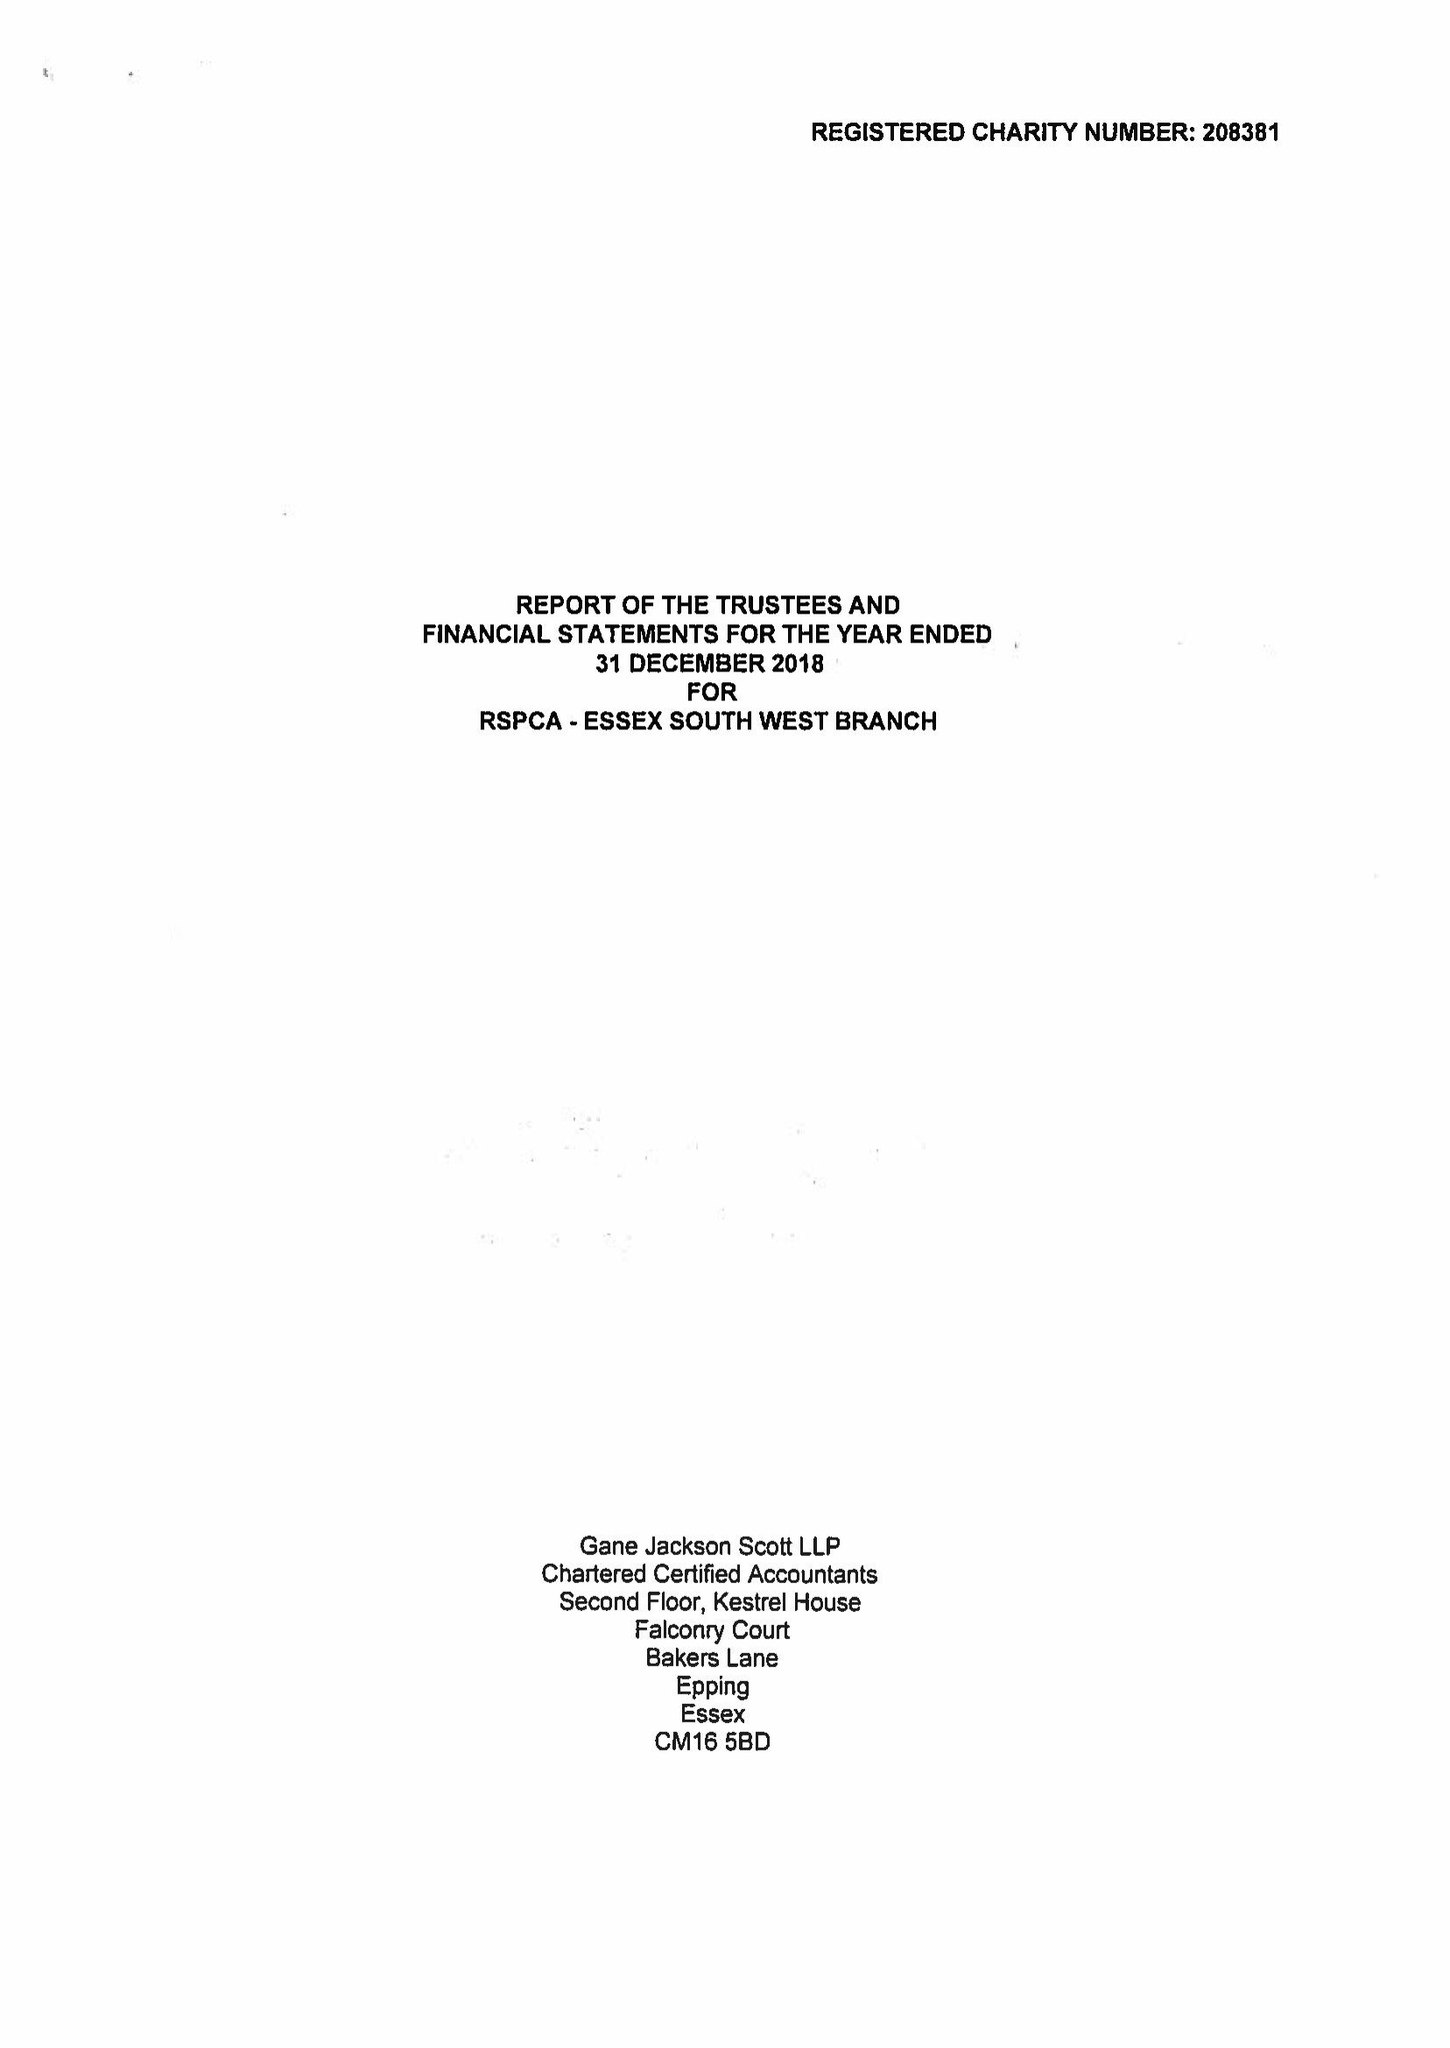What is the value for the address__postcode?
Answer the question using a single word or phrase. IG7 6QQ 